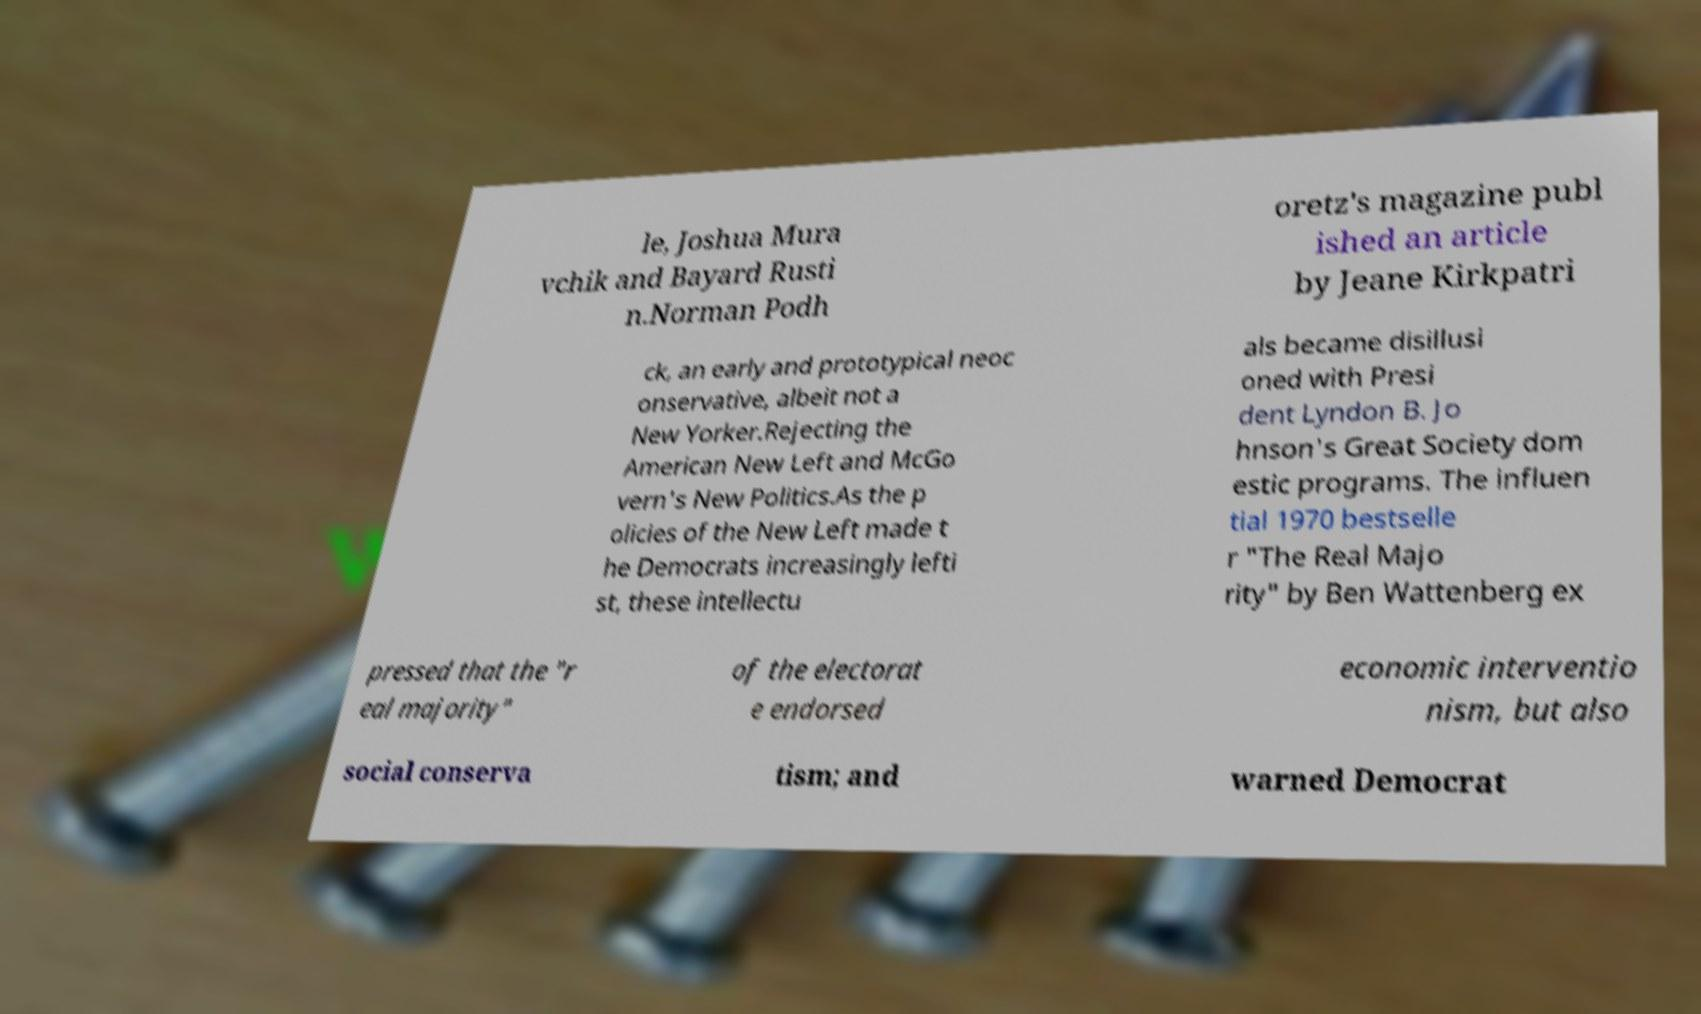There's text embedded in this image that I need extracted. Can you transcribe it verbatim? le, Joshua Mura vchik and Bayard Rusti n.Norman Podh oretz's magazine publ ished an article by Jeane Kirkpatri ck, an early and prototypical neoc onservative, albeit not a New Yorker.Rejecting the American New Left and McGo vern's New Politics.As the p olicies of the New Left made t he Democrats increasingly lefti st, these intellectu als became disillusi oned with Presi dent Lyndon B. Jo hnson's Great Society dom estic programs. The influen tial 1970 bestselle r "The Real Majo rity" by Ben Wattenberg ex pressed that the "r eal majority" of the electorat e endorsed economic interventio nism, but also social conserva tism; and warned Democrat 